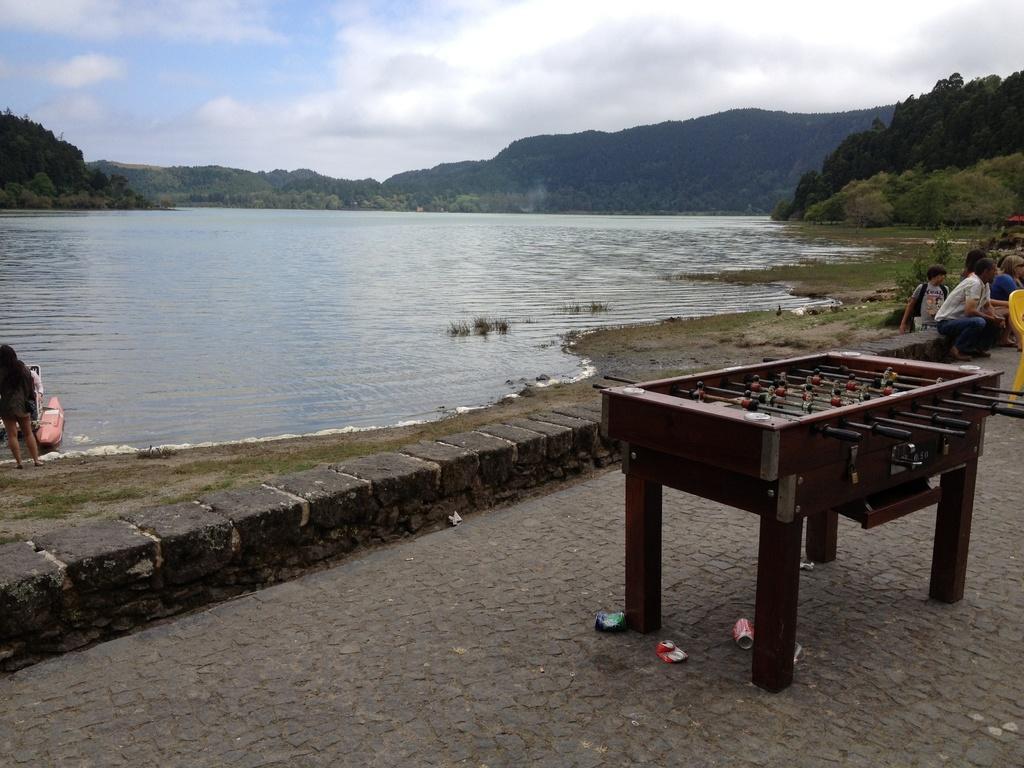Please provide a concise description of this image. In this image I can see a brown color football table, few cans, water, number of trees, clouds, the sky and here I can see few people where one is standing and rest all are sitting. I can also see a yellow color chair over here. 